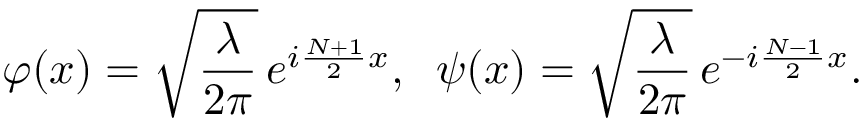<formula> <loc_0><loc_0><loc_500><loc_500>\varphi ( x ) = \sqrt { \frac { \lambda } { 2 \pi } } \, e ^ { i \frac { N + 1 } { 2 } x } , \, \psi ( x ) = \sqrt { \frac { \lambda } { 2 \pi } } \, e ^ { - i \frac { N - 1 } { 2 } x } .</formula> 